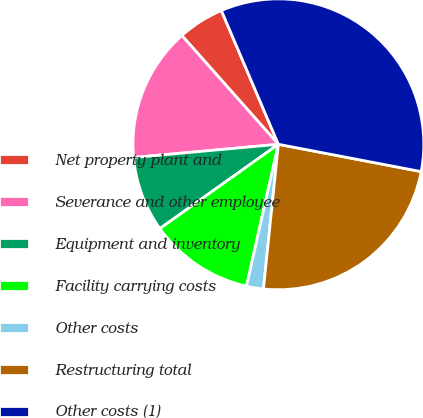Convert chart to OTSL. <chart><loc_0><loc_0><loc_500><loc_500><pie_chart><fcel>Net property plant and<fcel>Severance and other employee<fcel>Equipment and inventory<fcel>Facility carrying costs<fcel>Other costs<fcel>Restructuring total<fcel>Other costs (1)<nl><fcel>5.14%<fcel>14.9%<fcel>8.39%<fcel>11.64%<fcel>1.88%<fcel>23.63%<fcel>34.42%<nl></chart> 